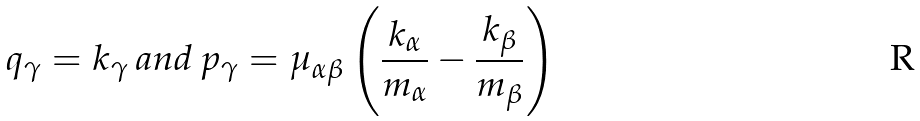<formula> <loc_0><loc_0><loc_500><loc_500>q _ { \gamma } = k _ { \gamma } \, a n d \, p _ { \gamma } = \mu _ { \alpha \beta } \left ( \frac { k _ { \alpha } } { m _ { \alpha } } - \frac { k _ { \beta } } { m _ { \beta } } \right )</formula> 